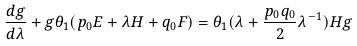Convert formula to latex. <formula><loc_0><loc_0><loc_500><loc_500>\frac { d g } { d \lambda } + g \theta _ { 1 } ( p _ { 0 } E + \lambda H + q _ { 0 } F ) = \theta _ { 1 } ( \lambda + \frac { p _ { 0 } q _ { 0 } } { 2 } \lambda ^ { - 1 } ) H g</formula> 